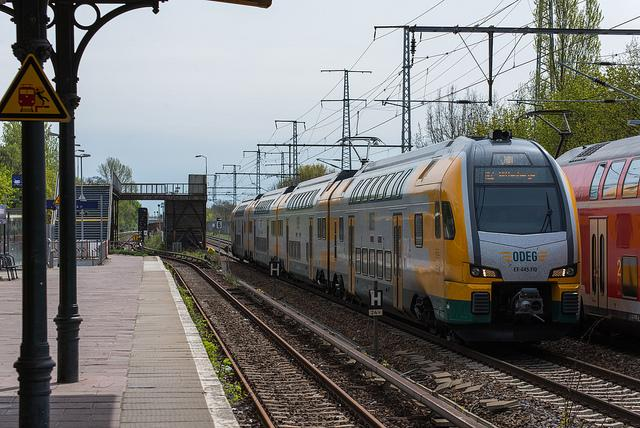What number is on the red train?

Choices:
A) nine
B) six
C) one
D) two two 